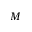<formula> <loc_0><loc_0><loc_500><loc_500>M</formula> 